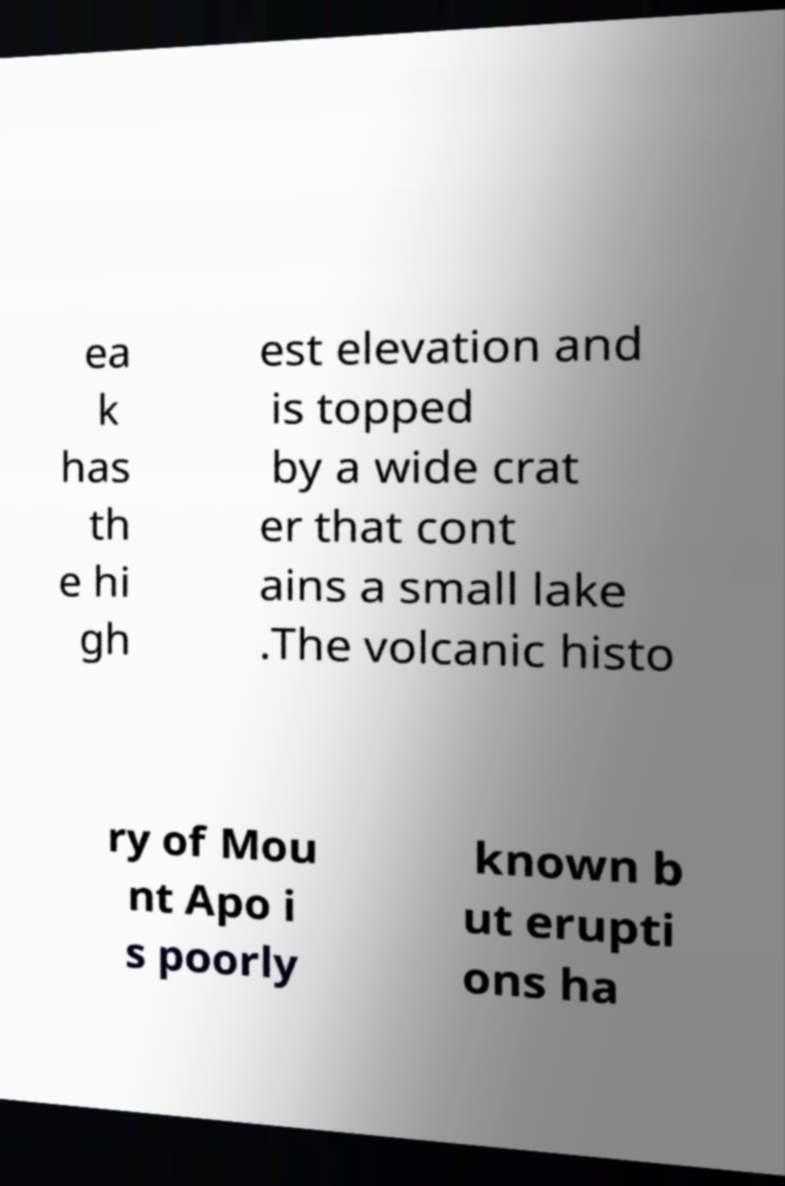Can you read and provide the text displayed in the image?This photo seems to have some interesting text. Can you extract and type it out for me? ea k has th e hi gh est elevation and is topped by a wide crat er that cont ains a small lake .The volcanic histo ry of Mou nt Apo i s poorly known b ut erupti ons ha 